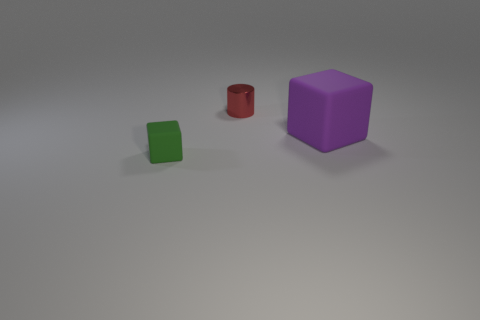Are there any other things that have the same size as the purple cube?
Provide a short and direct response. No. Is there any other thing that is made of the same material as the red cylinder?
Provide a succinct answer. No. Are there any other objects of the same size as the red object?
Ensure brevity in your answer.  Yes. What is the material of the cylinder that is the same size as the green block?
Your response must be concise. Metal. What number of green matte cubes are there?
Ensure brevity in your answer.  1. There is a block left of the big purple object; what size is it?
Your answer should be compact. Small. Are there the same number of large purple objects to the right of the large block and small objects?
Offer a very short reply. No. Is there another thing that has the same shape as the large purple rubber object?
Keep it short and to the point. Yes. What is the shape of the thing that is behind the green object and left of the purple matte thing?
Make the answer very short. Cylinder. Do the big thing and the block that is to the left of the purple rubber object have the same material?
Provide a succinct answer. Yes. 